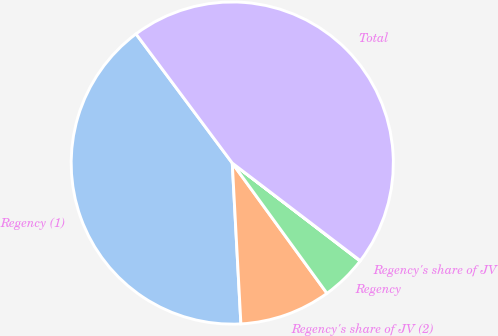<chart> <loc_0><loc_0><loc_500><loc_500><pie_chart><fcel>Regency (1)<fcel>Regency's share of JV (2)<fcel>Regency<fcel>Regency's share of JV<fcel>Total<nl><fcel>40.66%<fcel>9.15%<fcel>4.59%<fcel>0.04%<fcel>45.56%<nl></chart> 